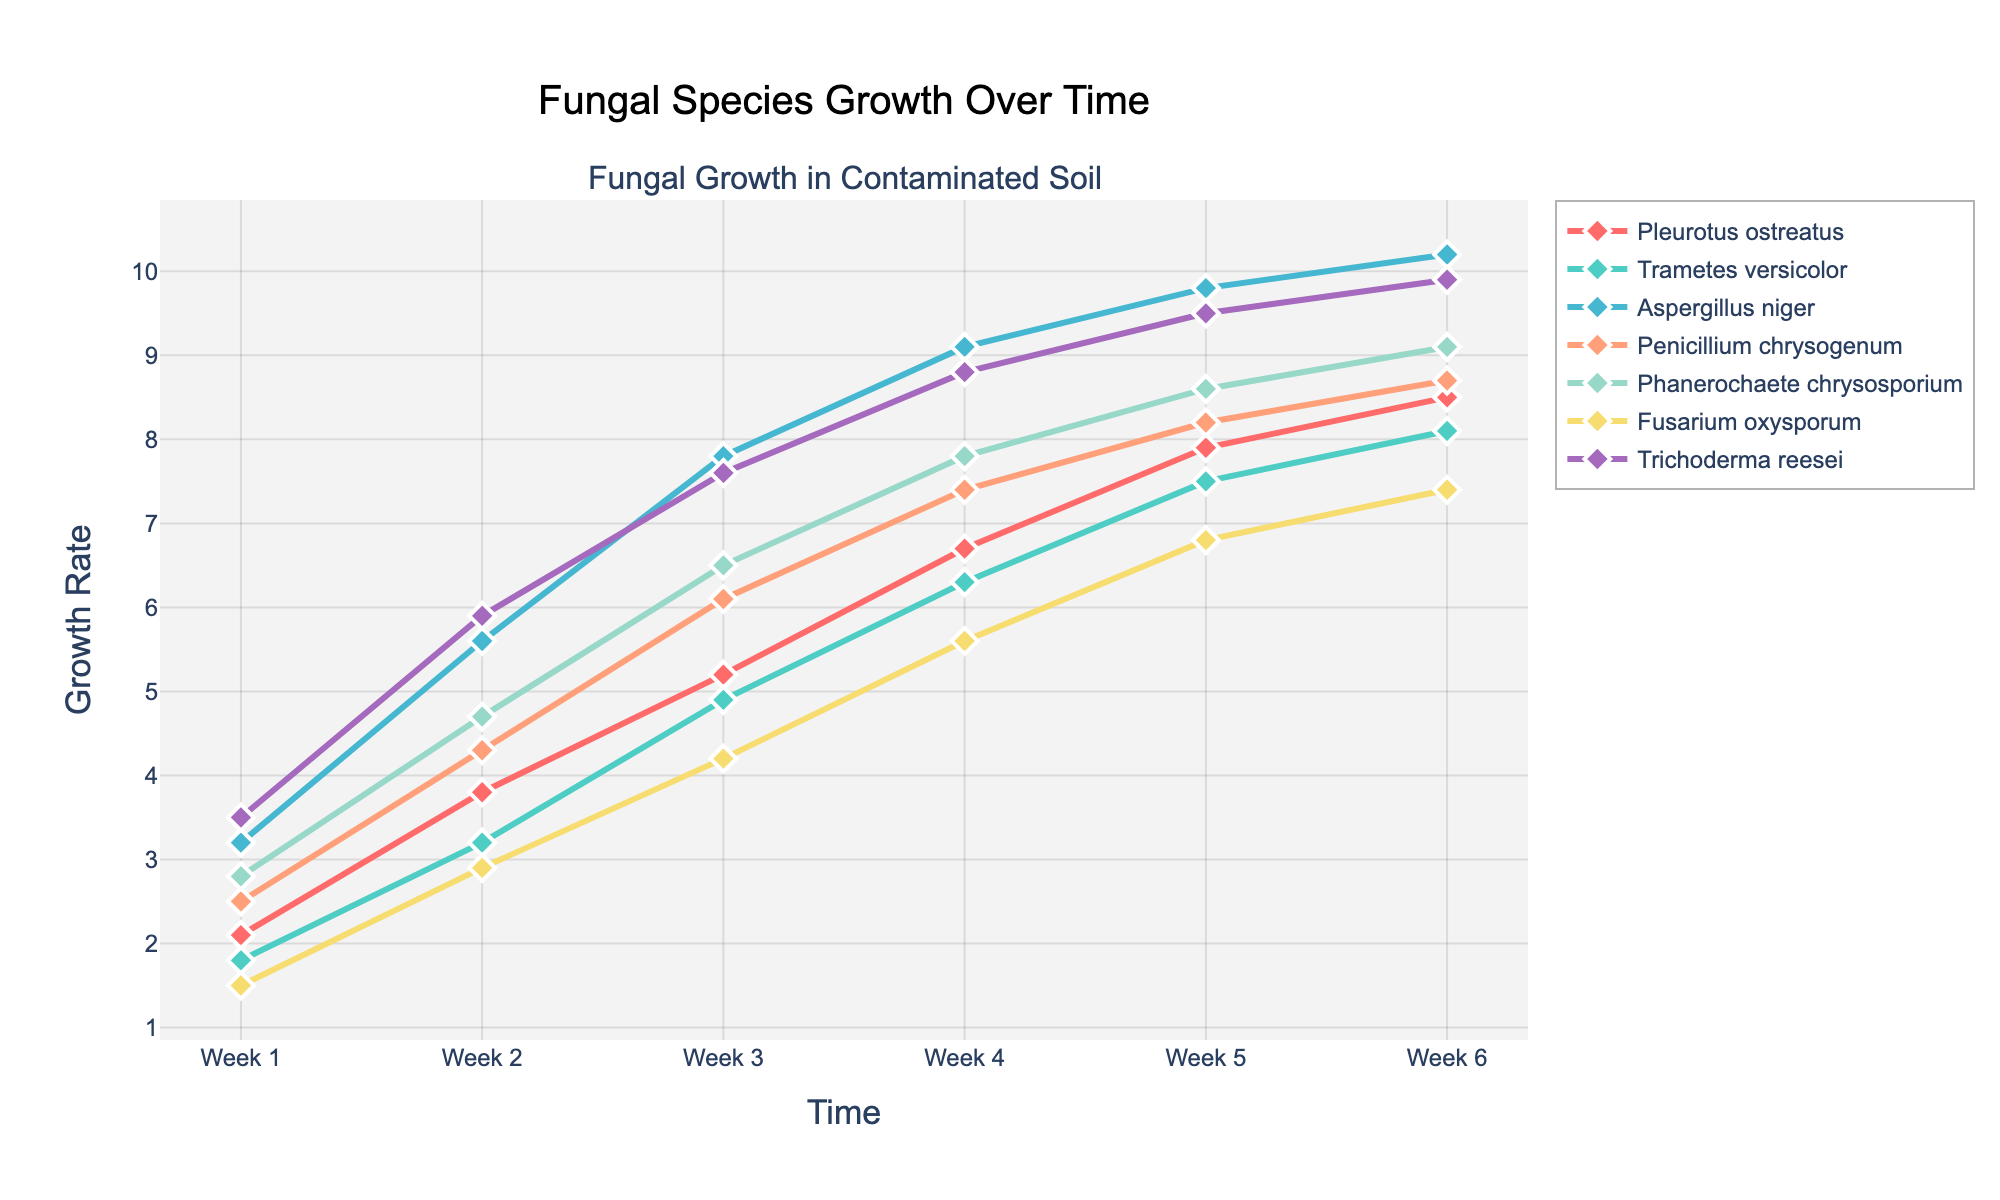which species shows the highest growth rate in Week 6? Look at the height of the lines at Week 6. The species that reaches the highest point on the y-axis is Aspergillus niger.
Answer: Aspergillus niger how much did the growth rate of Pleurotus ostreatus increase from Week 1 to Week 6? Subtract the growth rate value of Week 1 from the value of Week 6 for Pleurotus ostreatus. It’s 8.5 (Week 6) - 2.1 (Week 1) = 6.4.
Answer: 6.4 which species had the smallest growth rate change between Week 5 and Week 6? Compare the change in growth rate from Week 5 to Week 6 for all species. Fusarium oxysporum increased from 6.8 to 7.4, a change of 0.6, which is the smallest.
Answer: Fusarium oxysporum how do the growth rates of Trichoderma reesei and Penicillium chrysogenum compare in Week 3? Look at the values of both species in Week 3. Trichoderma reesei has a growth rate of 7.6 and Penicillium chrysogenum has a growth rate of 6.1, so Trichoderma reesei is higher.
Answer: Trichoderma reesei is higher which species had a faster average growth rate increase from Week 1 to Week 3: Pleurotus ostreatus or Phanerochaete chrysosporium? Calculate the average growth rate increase for both species from Week 1 to Week 3. For Pleurotus ostreatus: (5.2-2.1) / 2 = 1.55. For Phanerochaete chrysosporium: (6.5-2.8) / 2 = 1.85. Phanerochaete chrysosporium had a faster increase.
Answer: Phanerochaete chrysosporium in which week did Trametes versicolor surpass 7.0 in growth rate? Look at the growth rates of Trametes versicolor over the weeks and find where it passed 7.0. In Week 5, the value is 7.5, which is above 7.0.
Answer: Week 5 what is the growth rate difference between Aspergillus niger and Fusarium oxysporum in Week 4? Subtract the growth rate of Fusarium oxysporum in Week 4 from that of Aspergillus niger. The rates are 9.1 (Aspergillus niger) and 5.6 (Fusarium oxysporum), so the difference is 9.1 - 5.6 = 3.5.
Answer: 3.5 what is the average growth rate of Trametes versicolor across all six weeks? Sum the growth rates of Trametes versicolor for all six weeks and divide by 6. (1.8 + 3.2 + 4.9 + 6.3 + 7.5 + 8.1) / 6 = 31.8 / 6 = 5.3.
Answer: 5.3 